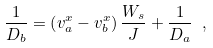<formula> <loc_0><loc_0><loc_500><loc_500>\frac { 1 } { D _ { b } } = \left ( v ^ { x } _ { a } - v ^ { x } _ { b } \right ) \frac { W _ { s } } { J } + \frac { 1 } { D _ { a } } \ ,</formula> 